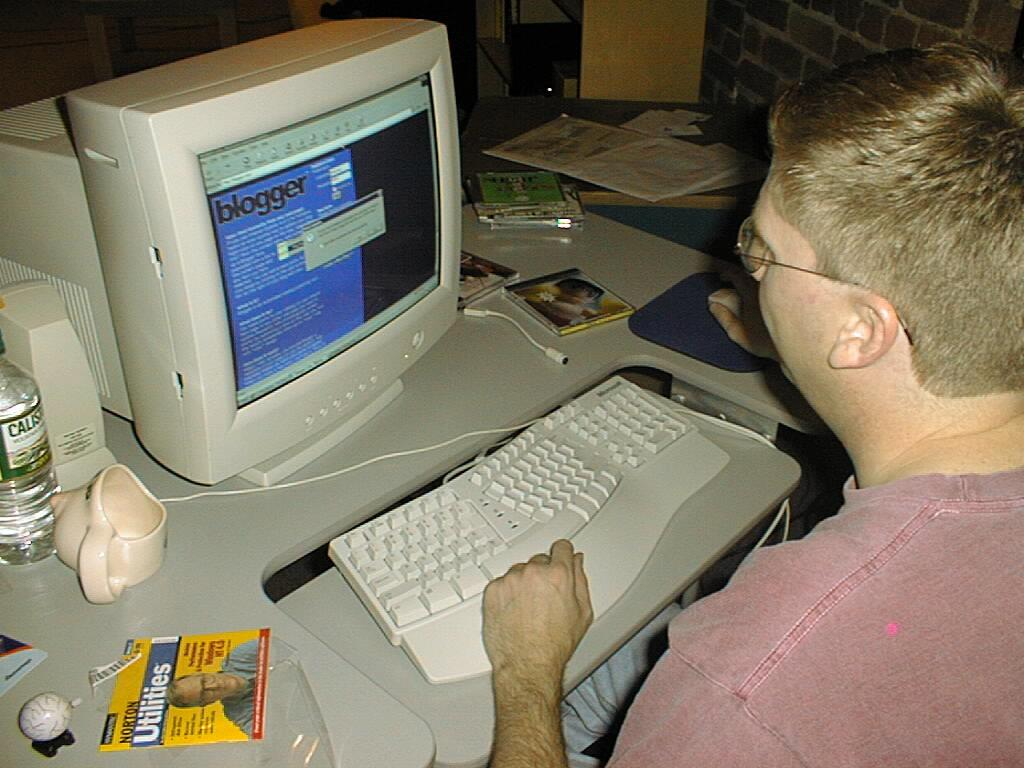What is the person holding in the image? The person is holding a mouse in the image. What type of system is visible in the image? There is a system in the image, which might be a computer system. What is used for typing in the image? A keyboard is visible in the image for typing. What are the two beverage containers present in the image? There is a bottle and a cup in the image. What might be used for writing or reading in the image? Papers are present in the image for writing or reading. What objects can be seen on the table in the image? There are objects on the table, including the system, keyboard, papers, bottle, and cup. What can be seen in the background of the image? There is a brick wall in the background of the image. What type of tooth is visible in the image? There is no tooth present in the image. What type of nail is being used by the person in the image? There is no nail being used by the person in the image. 